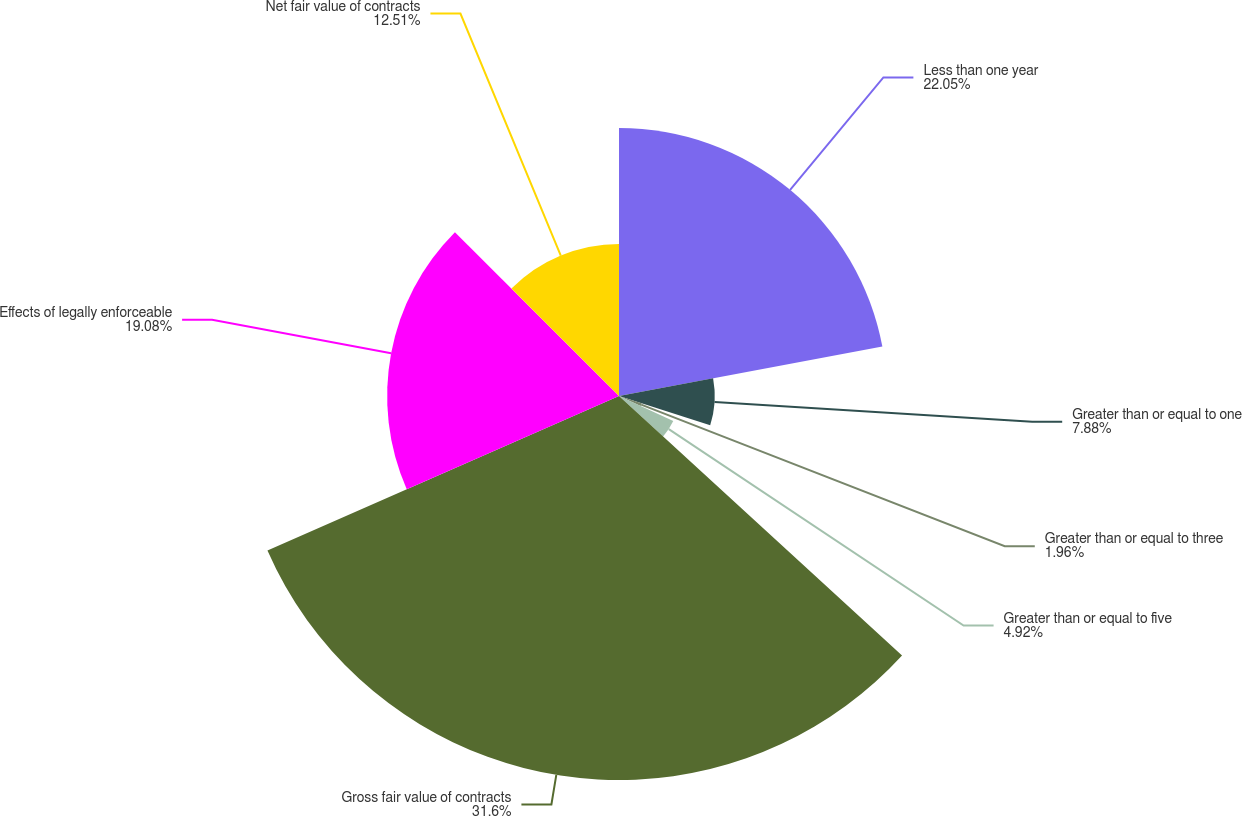Convert chart to OTSL. <chart><loc_0><loc_0><loc_500><loc_500><pie_chart><fcel>Less than one year<fcel>Greater than or equal to one<fcel>Greater than or equal to three<fcel>Greater than or equal to five<fcel>Gross fair value of contracts<fcel>Effects of legally enforceable<fcel>Net fair value of contracts<nl><fcel>22.05%<fcel>7.88%<fcel>1.96%<fcel>4.92%<fcel>31.6%<fcel>19.08%<fcel>12.51%<nl></chart> 